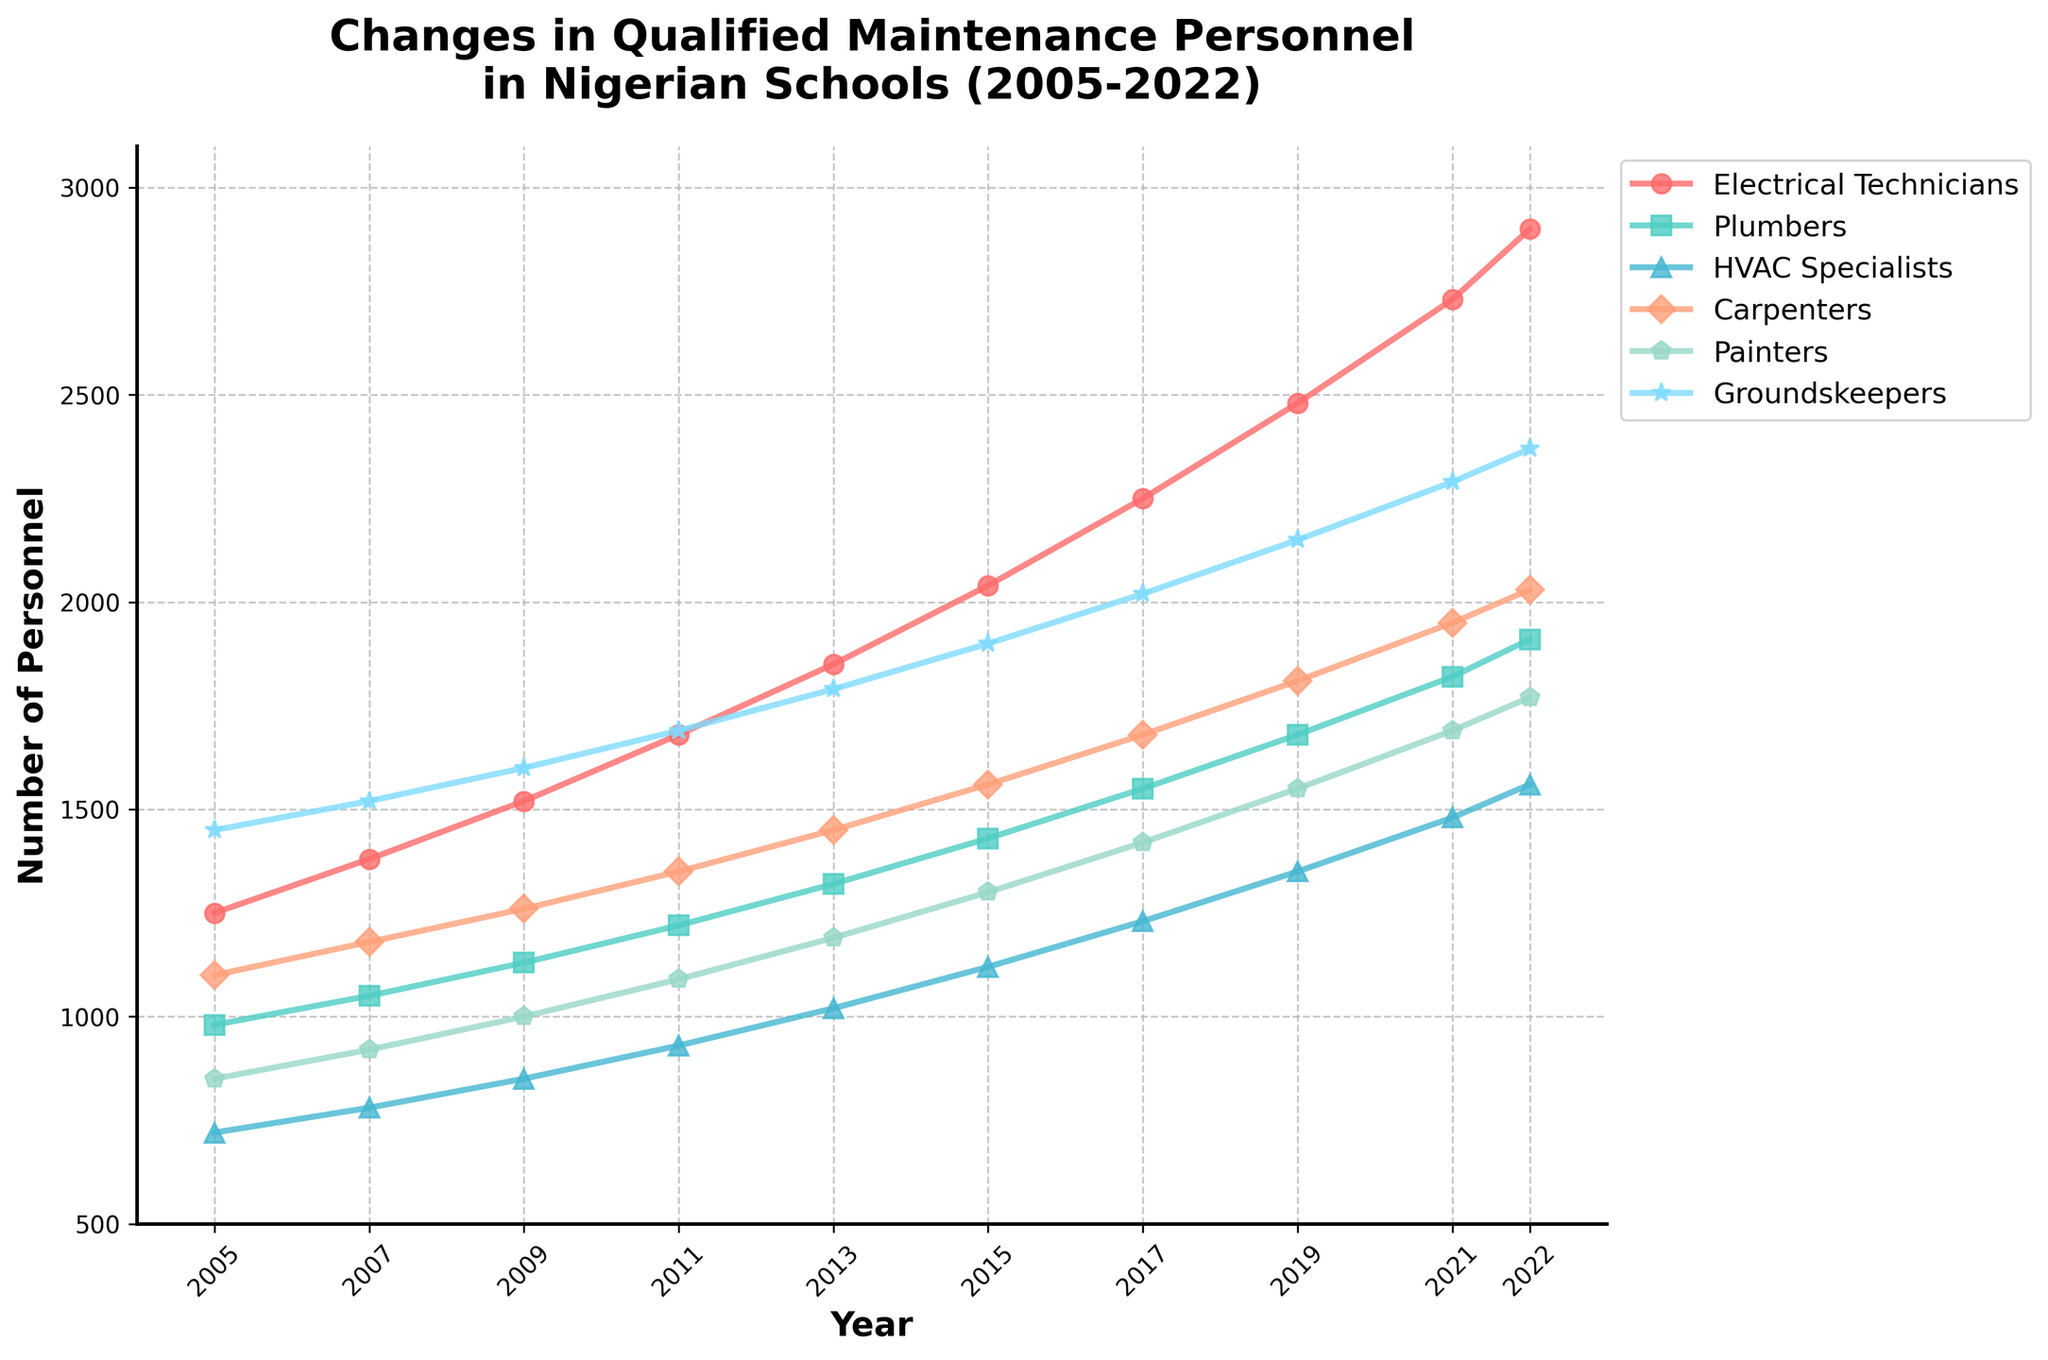Which specialization had the highest number of personnel in 2022? Look at the end points of all lines in 2022 and compare their heights. The line representing 'Groundskeepers' is the highest at that year.
Answer: Groundskeepers How many more HVAC Specialists than Painters were there in 2011? Locate the data points for HVAC Specialists and Painters in 2011. Subtract the number for Painters (1090) from HVAC Specialists (930).
Answer: 240 What is the overall trend for the number of Electrical Technicians from 2005 to 2022? Observe the line for Electrical Technicians which starts at 1250 in 2005 and continuously increases to 2900 in 2022. This is an upward trend.
Answer: Upward trend Between which two years did Carpenters see the highest increase in personnel? Compare the differences between consecutive years for Carpenters. The highest increase is from 2019 (1810) to 2021 (1950), an increase of 140.
Answer: 2019-2021 In which years were the numbers of Plumbers and Carpenters equal, if any? Compare the data points for Plumbers and Carpenters across all years. There are no years where the numbers are equal.
Answer: None What's the average number of Painters from 2005 to 2022? Sum all the numbers for Painters from each year, which is (850+920+1000+1090+1190+1300+1420+1550+1690+1770) = 12680. Divide by the number of years (10).
Answer: 1268 Which specialization experienced the least growth from 2005 to 2022? Calculate the growth for each specialization by subtracting their 2005 values from their 2022 values. HVAC Specialists had the smallest growth (1560 - 720 = 840).
Answer: HVAC Specialists By how much did the number of Groundskeepers increase from 2005 to 2015? Subtract the number of Groundskeepers in 2005 (1450) from the number in 2015 (1900).
Answer: 450 What is the difference in the number of personnel between Electricians and Groundskeepers in 2022? Subtract the number of Groundskeepers (2370) from Electrical Technicians (2900).
Answer: 530 Which specialization had the most consistent growth rate between the years, showing nearly equal intervals? Evaluate the lengths between points for each line. Plumbers show relatively consistent increments between intervals.
Answer: Plumbers 